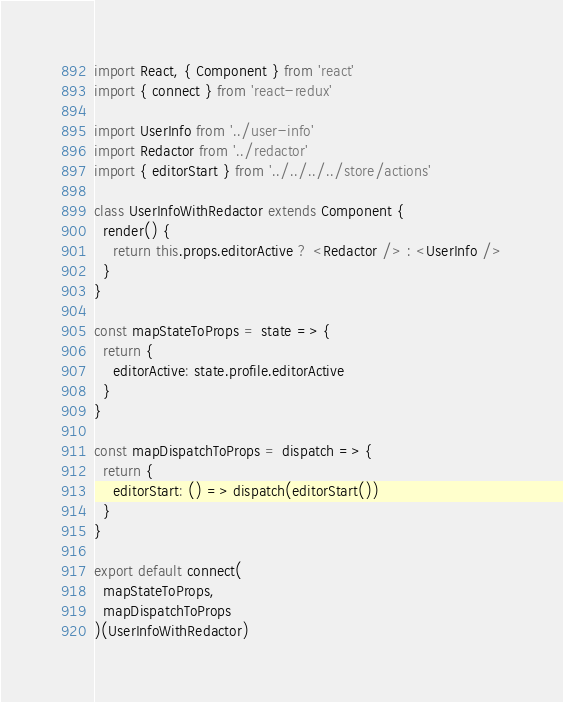Convert code to text. <code><loc_0><loc_0><loc_500><loc_500><_JavaScript_>import React, { Component } from 'react'
import { connect } from 'react-redux'

import UserInfo from '../user-info'
import Redactor from '../redactor'
import { editorStart } from '../../../../store/actions'

class UserInfoWithRedactor extends Component {
  render() {
    return this.props.editorActive ? <Redactor /> : <UserInfo />
  }
}

const mapStateToProps = state => {
  return {
    editorActive: state.profile.editorActive
  }
}

const mapDispatchToProps = dispatch => {
  return {
    editorStart: () => dispatch(editorStart())
  }
}

export default connect(
  mapStateToProps,
  mapDispatchToProps
)(UserInfoWithRedactor)
</code> 